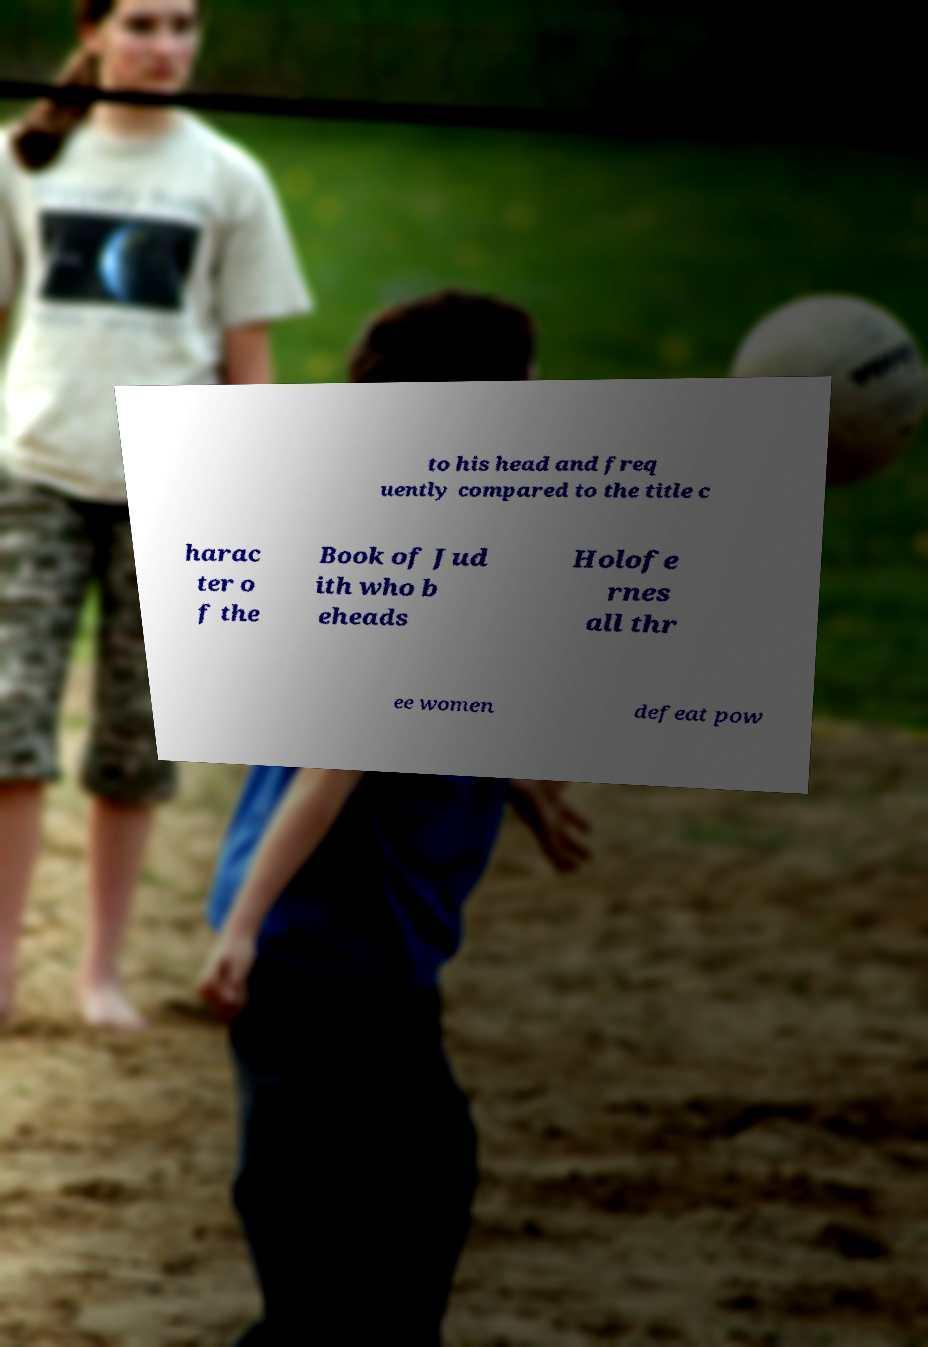There's text embedded in this image that I need extracted. Can you transcribe it verbatim? to his head and freq uently compared to the title c harac ter o f the Book of Jud ith who b eheads Holofe rnes all thr ee women defeat pow 